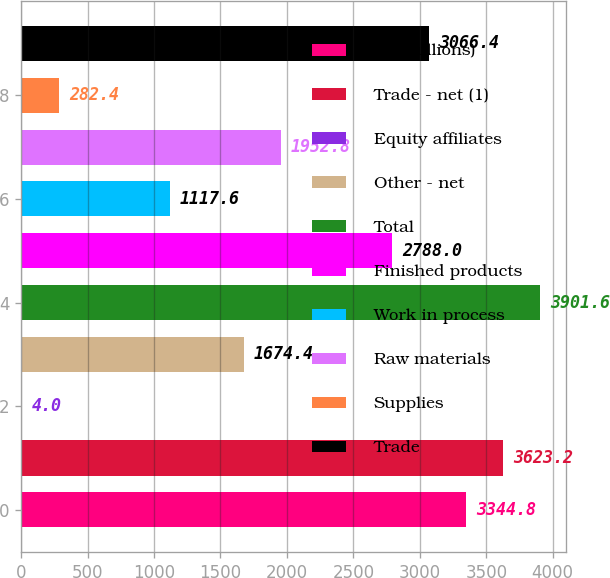Convert chart. <chart><loc_0><loc_0><loc_500><loc_500><bar_chart><fcel>( in millions)<fcel>Trade - net (1)<fcel>Equity affiliates<fcel>Other - net<fcel>Total<fcel>Finished products<fcel>Work in process<fcel>Raw materials<fcel>Supplies<fcel>Trade<nl><fcel>3344.8<fcel>3623.2<fcel>4<fcel>1674.4<fcel>3901.6<fcel>2788<fcel>1117.6<fcel>1952.8<fcel>282.4<fcel>3066.4<nl></chart> 